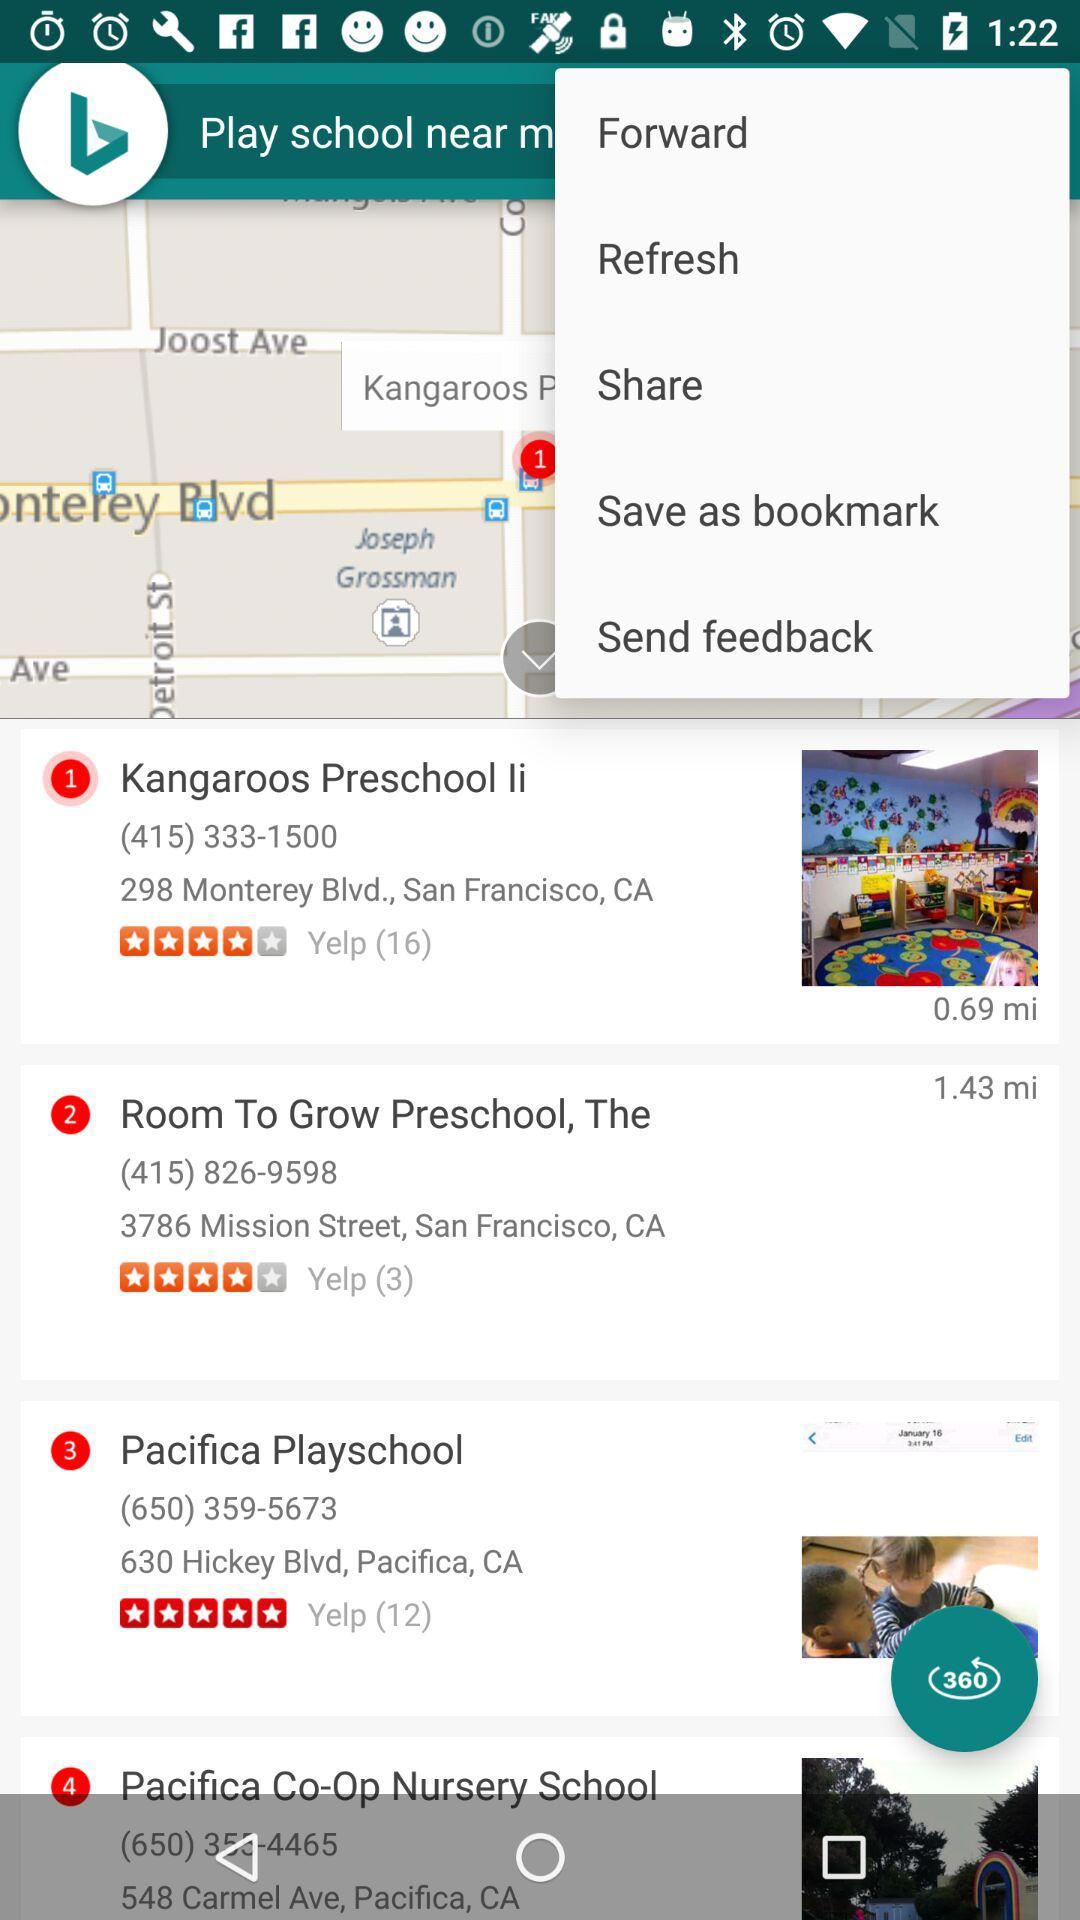How many miles away is the preschool with the lowest rating?
Answer the question using a single word or phrase. 1.43 